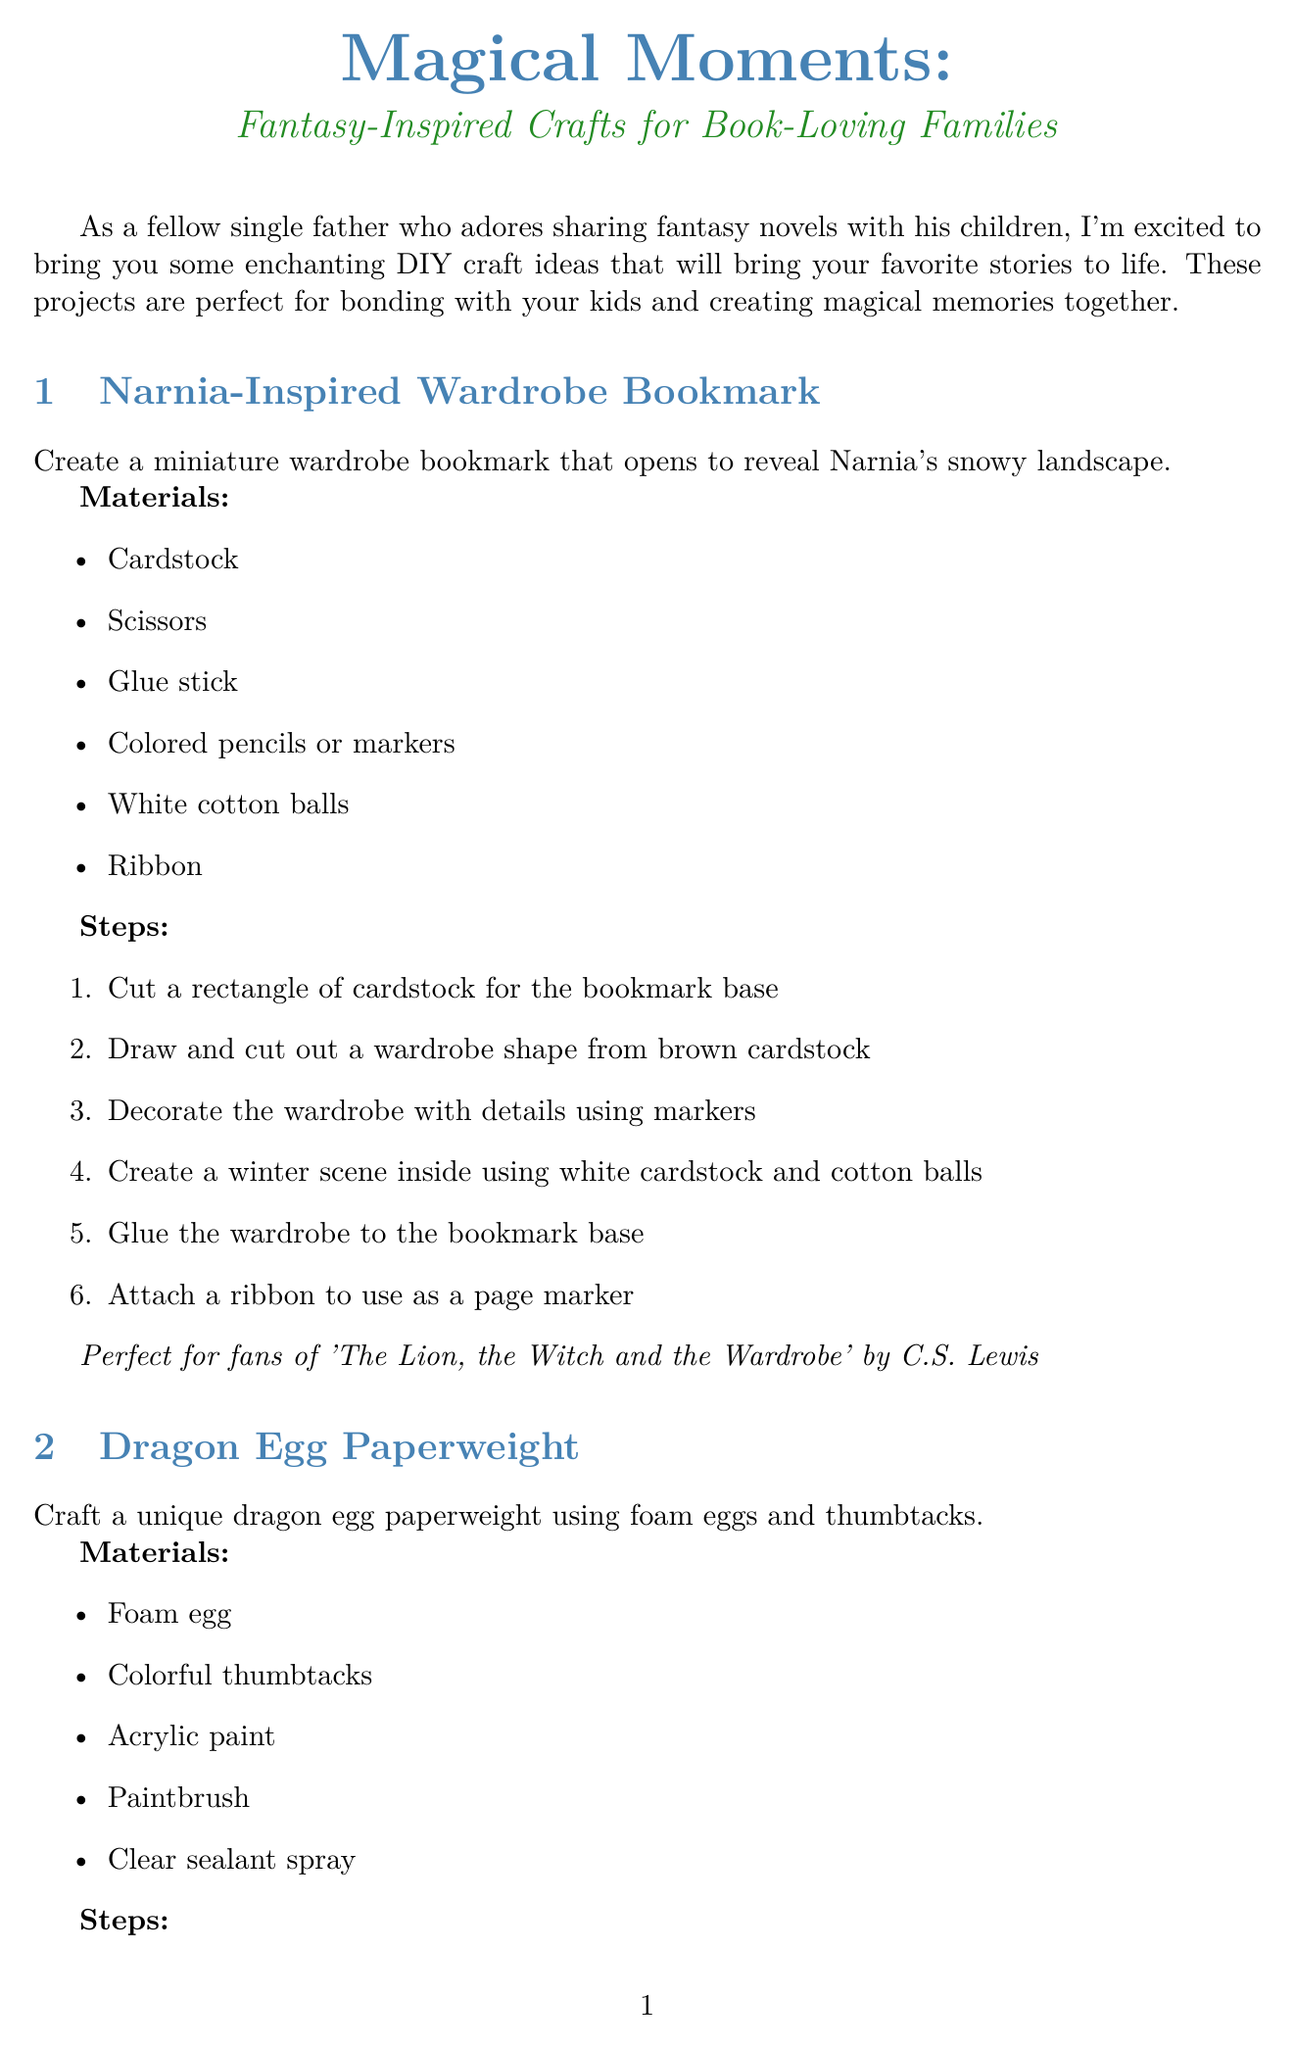What is the title of the newsletter? The title of the newsletter is stated at the beginning of the document.
Answer: Magical Moments: Fantasy-Inspired Crafts for Book-Loving Families How many craft ideas are presented in the newsletter? The number of craft ideas is listed in the craft ideas section of the document.
Answer: 3 What is the first craft idea mentioned? The first craft idea is detailed in the craft ideas section, listing its name.
Answer: Narnia-Inspired Wardrobe Bookmark Which movie's dragon eggs inspired the second craft idea? The document mentions inspirations for the craft ideas, including specific titles.
Answer: Game of Thrones or Eragon What materials are needed for the Wizard's Wand? The materials section lists the items required for the Wizard's Wand project.
Answer: Wooden chopstick, Polymer clay in various colors, Acrylic paint, Paintbrush, Clear nail polish, Sandpaper What is the suggested activity for the book club meeting? The document proposes an activity to engage book club members while discussing books.
Answer: Craft night What is the main theme of the crafts suggested? The introduction outlines the overall theme of the crafted projects in the newsletter.
Answer: Fantasy-Inspired What is the concluding message of the newsletter? The conclusion reinforces the importance of spending time together while engaging in the crafts.
Answer: Time spent together, sharing stories and creating memories 